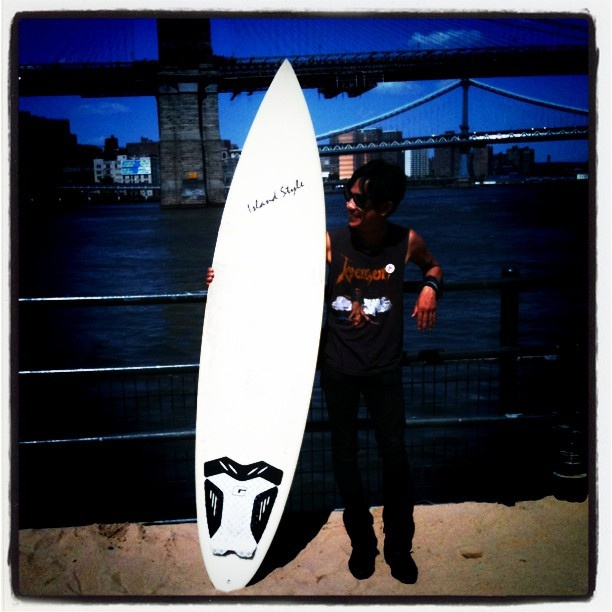Describe the objects in this image and their specific colors. I can see surfboard in white, black, gray, and darkgray tones and people in white, black, maroon, and gray tones in this image. 